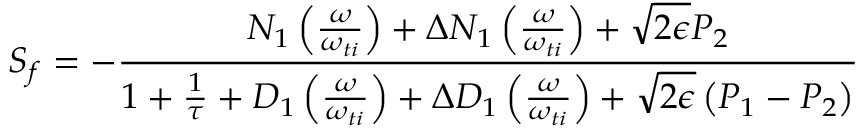<formula> <loc_0><loc_0><loc_500><loc_500>{ S _ { f } } = - \frac { N _ { 1 } \left ( \frac { \omega } { \omega _ { t i } } \right ) + \Delta N _ { 1 } \left ( \frac { \omega } { \omega _ { t i } } \right ) + \sqrt { 2 \epsilon } P _ { 2 } } { 1 + \frac { 1 } { \tau } + D _ { 1 } \left ( \frac { \omega } { \omega _ { t i } } \right ) + \Delta D _ { 1 } \left ( \frac { \omega } { \omega _ { t i } } \right ) + \sqrt { 2 \epsilon } \left ( P _ { 1 } - P _ { 2 } \right ) }</formula> 